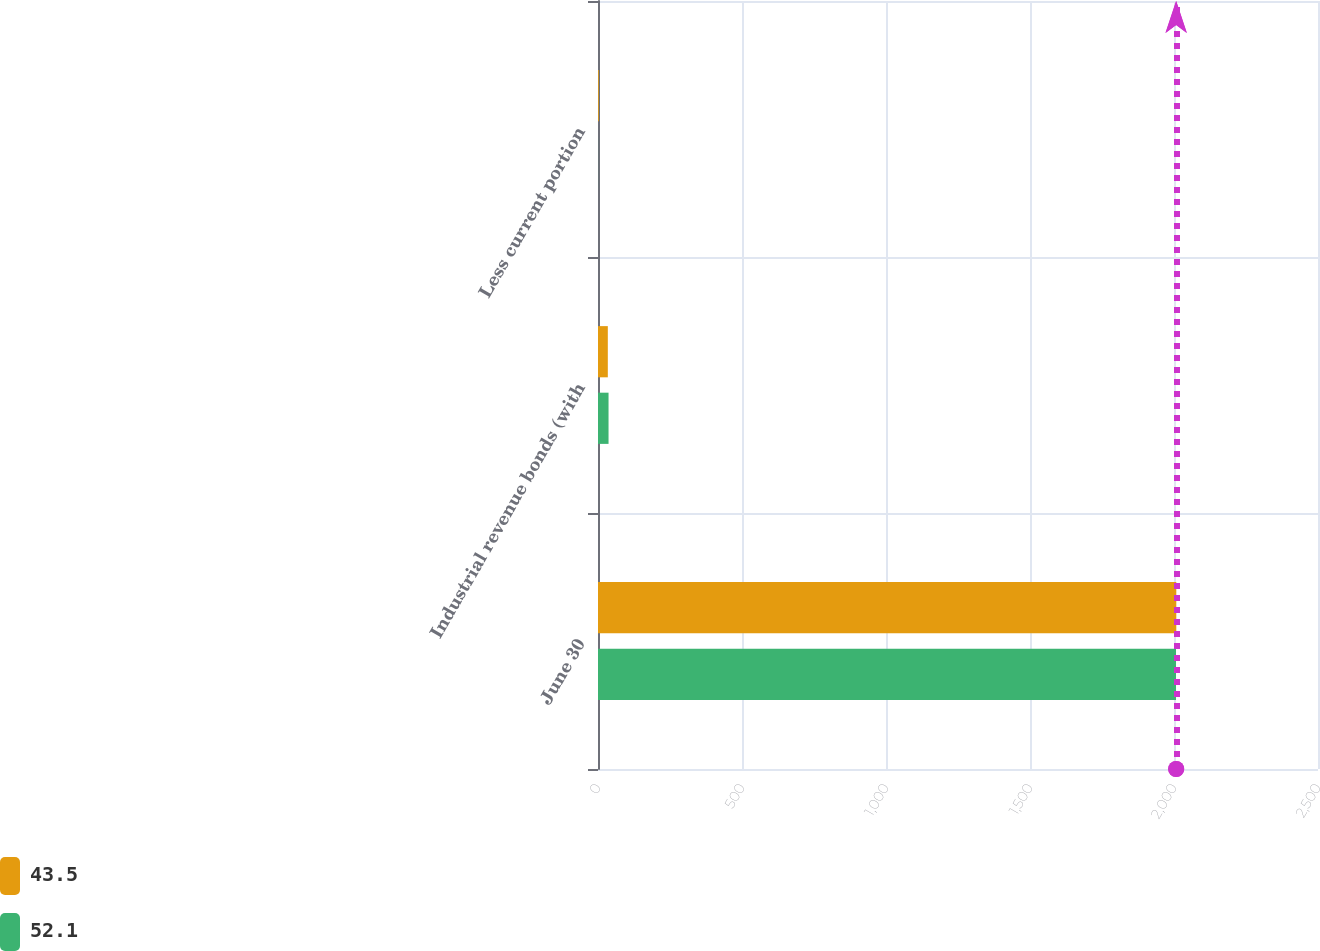<chart> <loc_0><loc_0><loc_500><loc_500><stacked_bar_chart><ecel><fcel>June 30<fcel>Industrial revenue bonds (with<fcel>Less current portion<nl><fcel>43.5<fcel>2008<fcel>34.1<fcel>2.7<nl><fcel>52.1<fcel>2007<fcel>36.6<fcel>0.2<nl></chart> 